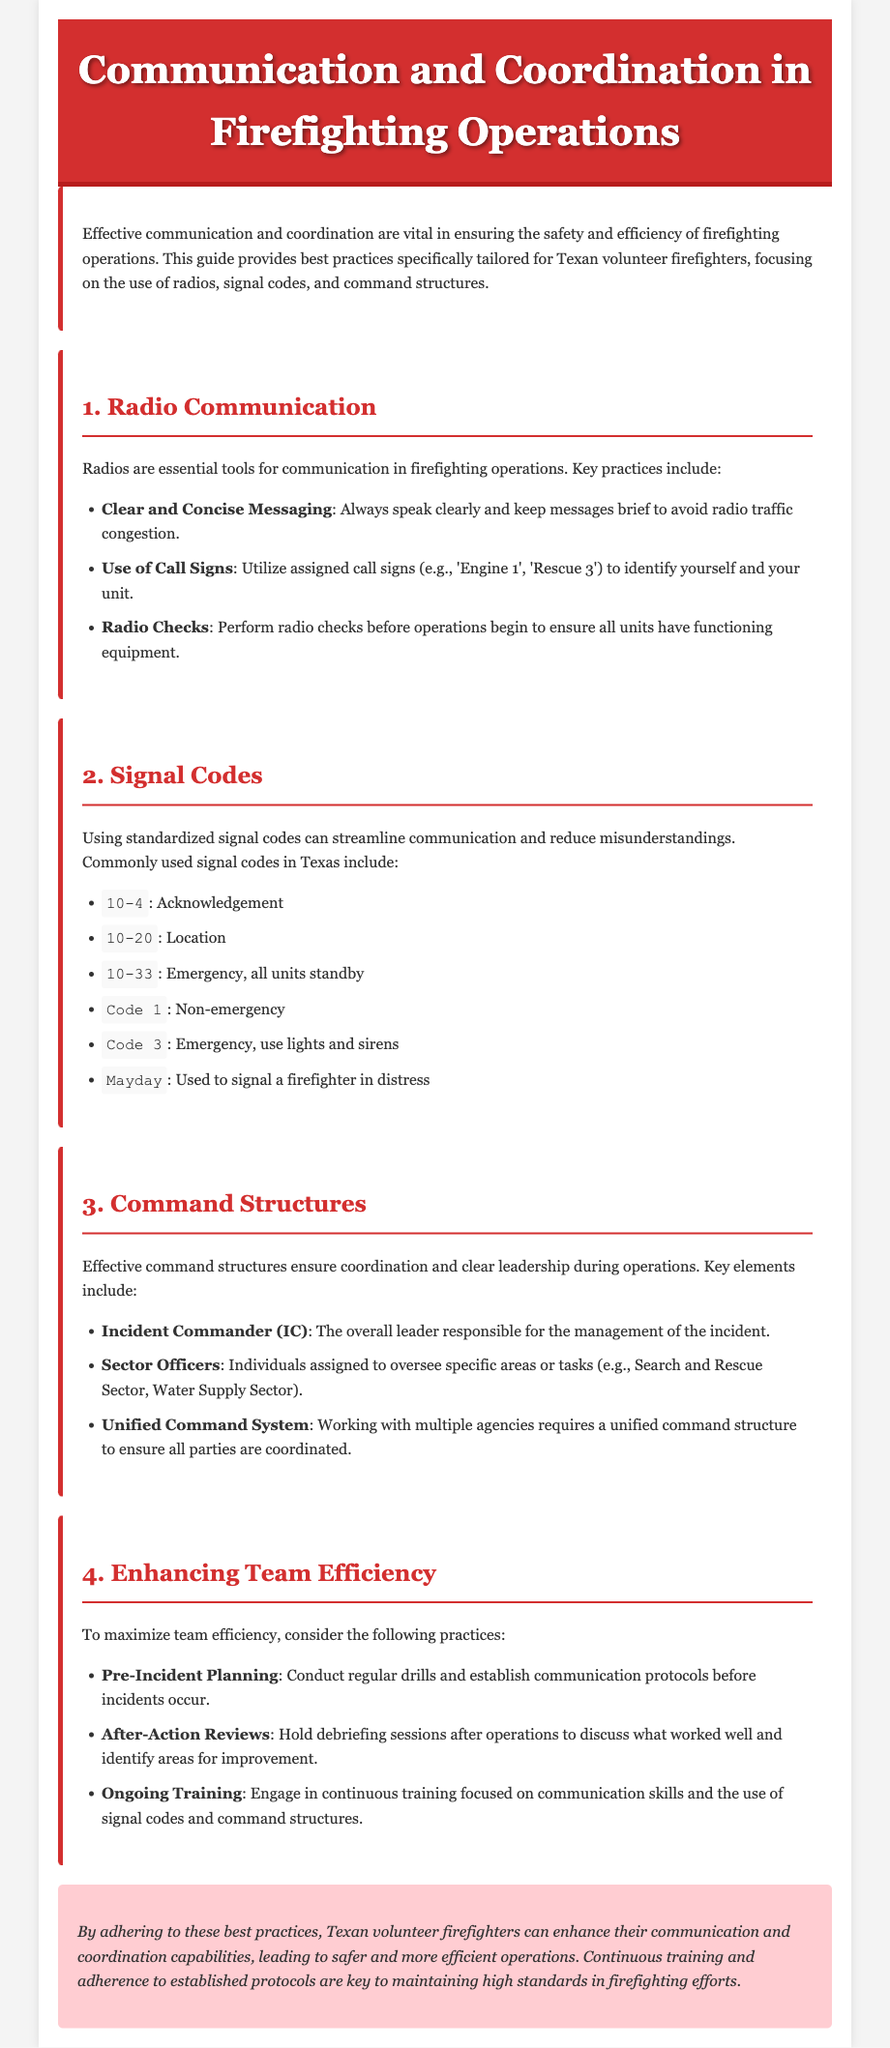What is the purpose of the guide? The guide provides best practices specifically tailored for Texan volunteer firefighters, focusing on effective communication and coordination in firefighting operations.
Answer: Best practices for Texan volunteer firefighters What code indicates an emergency situation? The document lists signal codes that are used during operations, including codes for emergencies.
Answer: Code 3 Who is the overall leader responsible for the incident management? The command structure in firefighting outlines different roles and their responsibilities.
Answer: Incident Commander What is one of the key elements of enhancing team efficiency? The document discusses practices that can maximize team efficiency during operations.
Answer: Pre-Incident Planning What does "10-33" signify? The document defines various signal codes used in firefighting communication for clarity.
Answer: Emergency, all units standby What is performed before operations to ensure communication equipment is functioning? The guide emphasizes the importance of checking communication tools before starting operations.
Answer: Radio checks How can teams improve their performance after incidents? The guide suggests ways to reflect on actions and enhance future operations.
Answer: After-Action Reviews What role oversees specific areas in firefighting operations? The document describes roles within the command structure and their specific responsibilities.
Answer: Sector Officers 